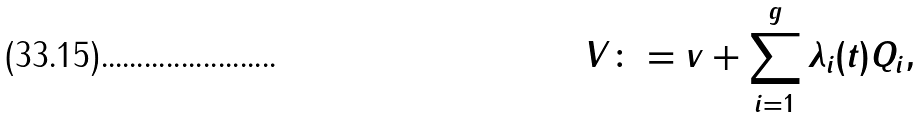Convert formula to latex. <formula><loc_0><loc_0><loc_500><loc_500>V \colon = { v } + \sum _ { i = 1 } ^ { g } \lambda _ { i } ( t ) { Q } _ { i } ,</formula> 